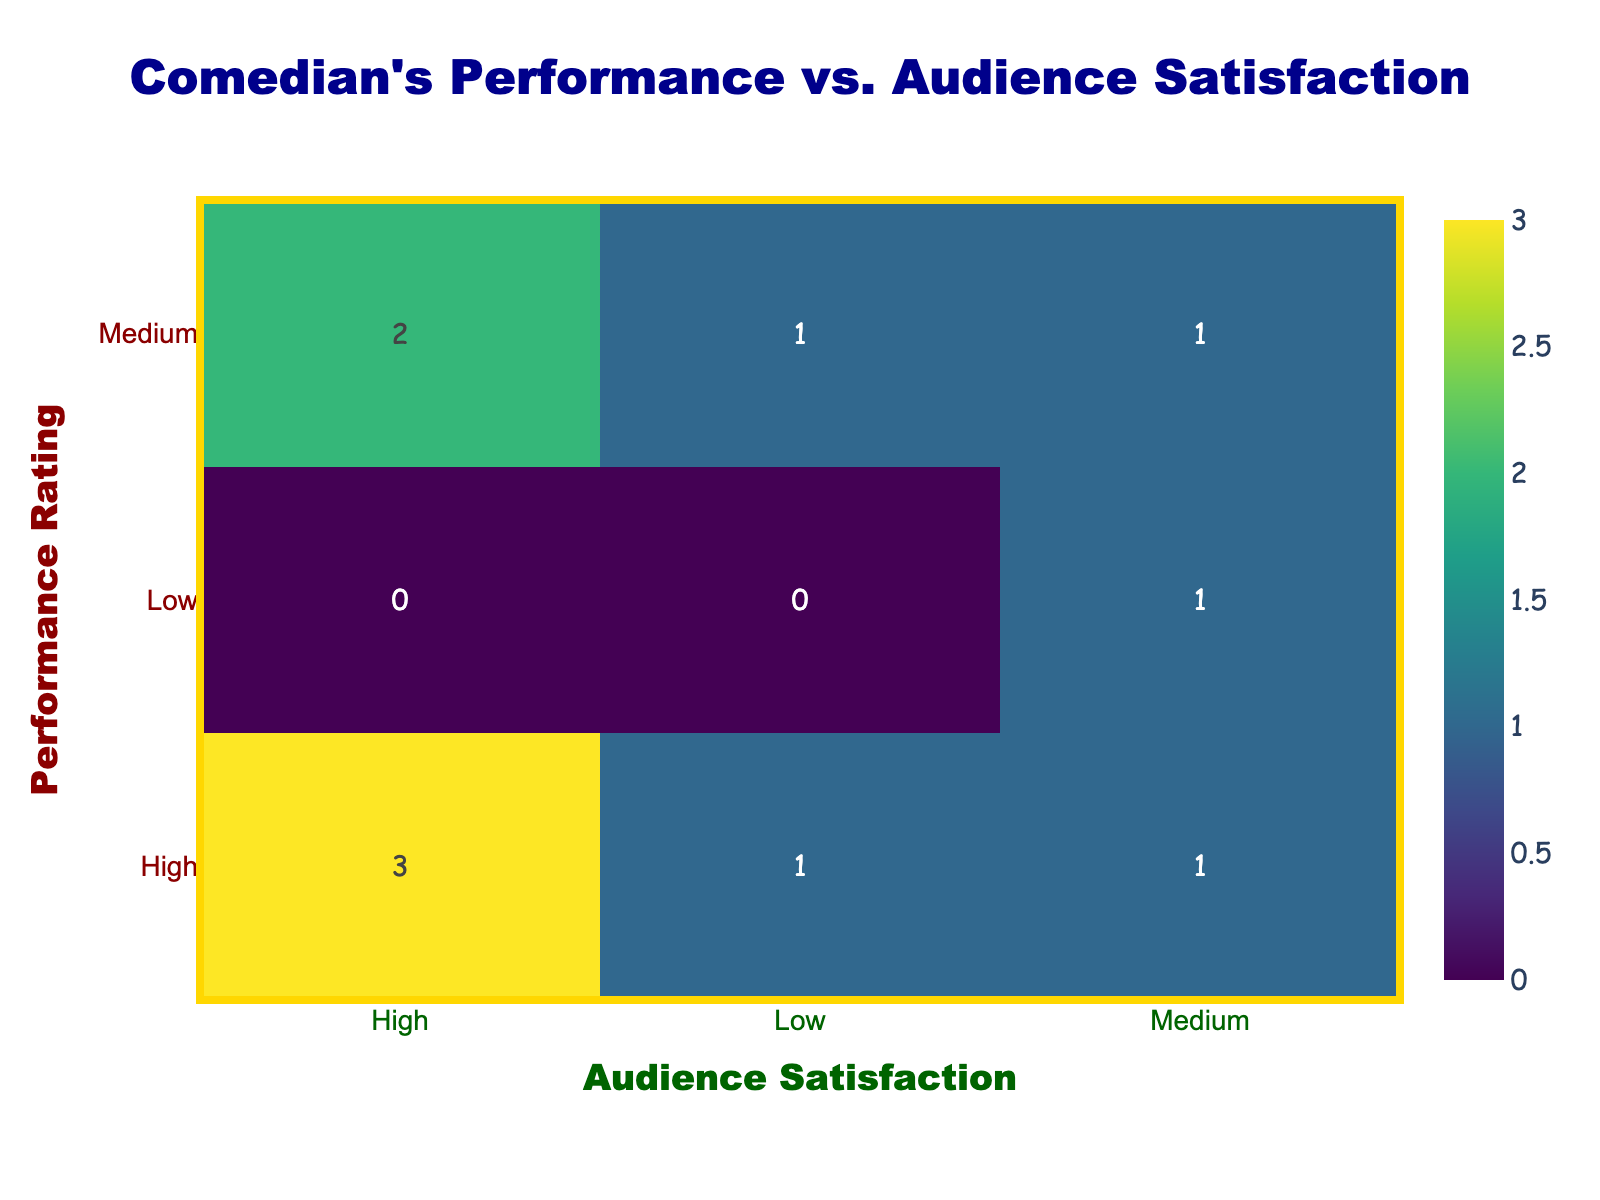What is the Performance Rating for Dave Chappelle? According to the table, Dave Chappelle has a Performance Rating of High.
Answer: High How many comedians received a Medium rating in Audience Satisfaction? From the table, Ricky Gervais and Kevin Hart received a Medium rating in Audience Satisfaction. Therefore, there are 2 comedians with this rating.
Answer: 2 Is it true that all comedians with a High Performance Rating also have High Audience Satisfaction? Chris Rock has a High Performance Rating but only received a Low Audience Satisfaction rating. Therefore, it is not true that all comedians with a High Performance Rating have High Audience Satisfaction.
Answer: No What is the combined count of comedians who received High in Performance Rating and Medium in Audience Satisfaction? The only comedian meeting this condition is Kevin Hart. This means there is 1 comedian who received a High Performance Rating and Medium Audience Satisfaction.
Answer: 1 Which Performance Rating received the lowest Audience Satisfaction? In the table, the Performance Rating of Low corresponds to an Audience Satisfaction of Medium (Sarah Silverman). However, since it doesn't get a Low in Audience Satisfaction, we notice that Medium Performance with Low Audience Satisfaction (Ricky Gervais) has the lowest satisfaction.
Answer: Medium What is the total number of comedians represented in the table? There are 10 comedians listed in the table, making for a total of 10.
Answer: 10 How many comedians have received High ratings in both Performance Rating and Audience Satisfaction? The table shows that Dave Chappelle, Amy Schumer, and Bill Burr all have High ratings in both Performance Rating and Audience Satisfaction. This results in a total of 3 comedians.
Answer: 3 Which comedian has the highest Performance Rating and what is their Audience Satisfaction? Both Dave Chappelle and Amy Schumer received High in Performance Rating, whereas Dave Chappelle also had High in Audience Satisfaction.
Answer: Dave Chappelle, High What is the average count of comedians across the different Performance Ratings? There are 10 comedians distributed across three Performance ratings: High (5), Medium (4), and Low (1). The average can be computed as (5 + 4 + 1) / 3 = 10 / 3 which results in approximately 3.33 comedians per Performance Rating category.
Answer: 3.33 